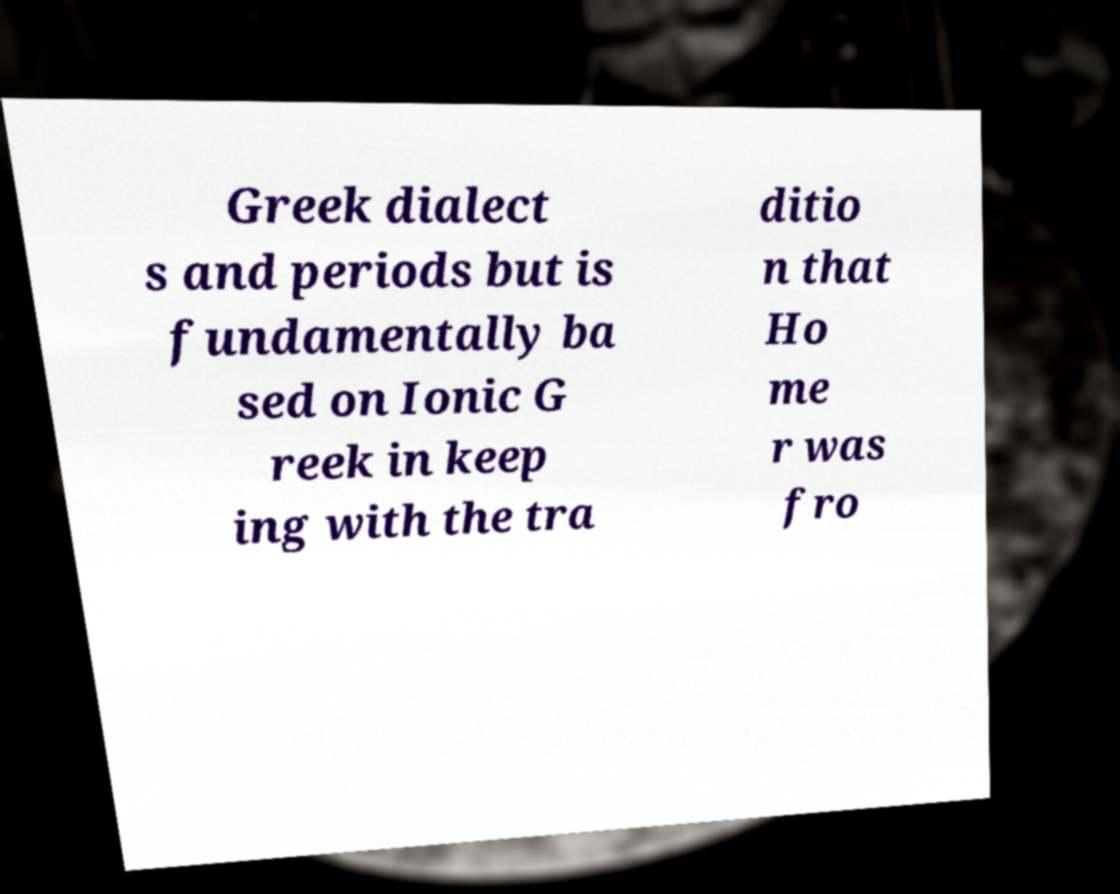Can you read and provide the text displayed in the image?This photo seems to have some interesting text. Can you extract and type it out for me? Greek dialect s and periods but is fundamentally ba sed on Ionic G reek in keep ing with the tra ditio n that Ho me r was fro 